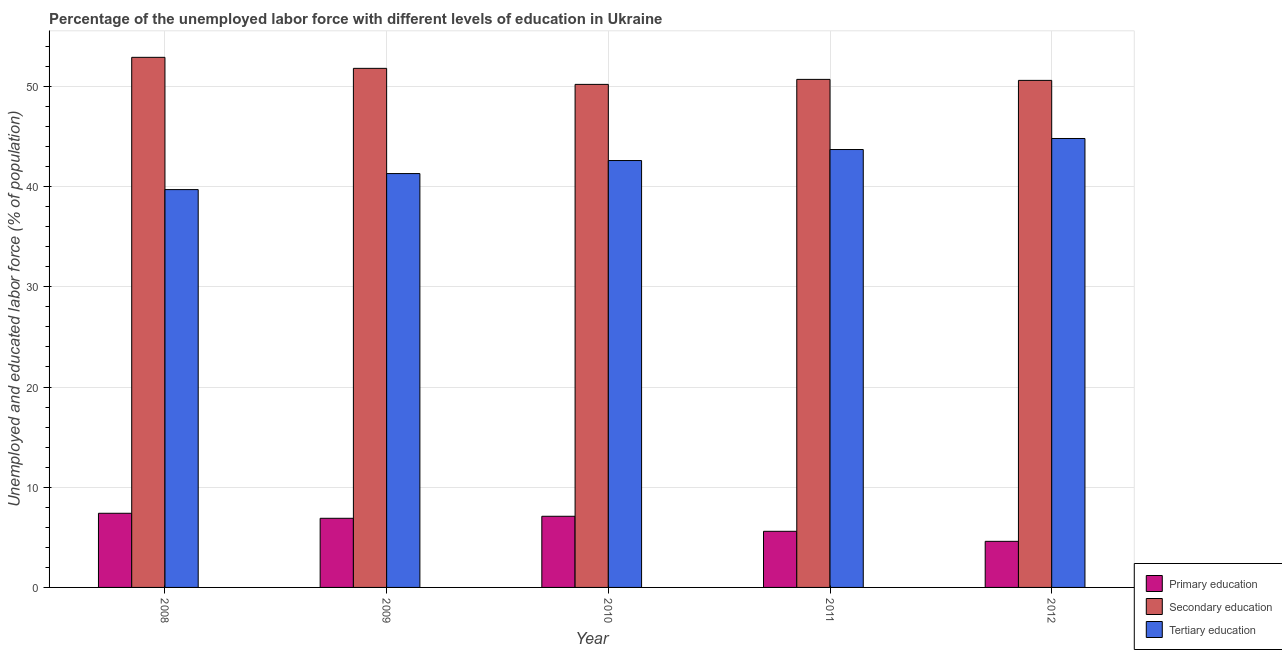How many groups of bars are there?
Provide a succinct answer. 5. Are the number of bars per tick equal to the number of legend labels?
Make the answer very short. Yes. What is the label of the 5th group of bars from the left?
Provide a short and direct response. 2012. In how many cases, is the number of bars for a given year not equal to the number of legend labels?
Offer a terse response. 0. What is the percentage of labor force who received tertiary education in 2009?
Make the answer very short. 41.3. Across all years, what is the maximum percentage of labor force who received primary education?
Make the answer very short. 7.4. Across all years, what is the minimum percentage of labor force who received primary education?
Keep it short and to the point. 4.6. In which year was the percentage of labor force who received tertiary education minimum?
Provide a succinct answer. 2008. What is the total percentage of labor force who received secondary education in the graph?
Your answer should be very brief. 256.2. What is the difference between the percentage of labor force who received tertiary education in 2009 and that in 2012?
Make the answer very short. -3.5. What is the difference between the percentage of labor force who received tertiary education in 2010 and the percentage of labor force who received secondary education in 2009?
Make the answer very short. 1.3. What is the average percentage of labor force who received secondary education per year?
Offer a very short reply. 51.24. What is the ratio of the percentage of labor force who received primary education in 2009 to that in 2012?
Give a very brief answer. 1.5. Is the difference between the percentage of labor force who received tertiary education in 2008 and 2011 greater than the difference between the percentage of labor force who received secondary education in 2008 and 2011?
Offer a very short reply. No. What is the difference between the highest and the second highest percentage of labor force who received secondary education?
Give a very brief answer. 1.1. What is the difference between the highest and the lowest percentage of labor force who received secondary education?
Give a very brief answer. 2.7. In how many years, is the percentage of labor force who received primary education greater than the average percentage of labor force who received primary education taken over all years?
Give a very brief answer. 3. What does the 1st bar from the left in 2012 represents?
Keep it short and to the point. Primary education. What does the 2nd bar from the right in 2012 represents?
Your answer should be very brief. Secondary education. Is it the case that in every year, the sum of the percentage of labor force who received primary education and percentage of labor force who received secondary education is greater than the percentage of labor force who received tertiary education?
Your response must be concise. Yes. How many bars are there?
Make the answer very short. 15. How many years are there in the graph?
Your answer should be compact. 5. What is the difference between two consecutive major ticks on the Y-axis?
Ensure brevity in your answer.  10. Are the values on the major ticks of Y-axis written in scientific E-notation?
Offer a terse response. No. Does the graph contain any zero values?
Provide a succinct answer. No. Does the graph contain grids?
Your response must be concise. Yes. Where does the legend appear in the graph?
Provide a short and direct response. Bottom right. How many legend labels are there?
Offer a terse response. 3. What is the title of the graph?
Your answer should be compact. Percentage of the unemployed labor force with different levels of education in Ukraine. What is the label or title of the X-axis?
Offer a terse response. Year. What is the label or title of the Y-axis?
Provide a succinct answer. Unemployed and educated labor force (% of population). What is the Unemployed and educated labor force (% of population) in Primary education in 2008?
Your answer should be compact. 7.4. What is the Unemployed and educated labor force (% of population) in Secondary education in 2008?
Ensure brevity in your answer.  52.9. What is the Unemployed and educated labor force (% of population) in Tertiary education in 2008?
Give a very brief answer. 39.7. What is the Unemployed and educated labor force (% of population) in Primary education in 2009?
Your answer should be compact. 6.9. What is the Unemployed and educated labor force (% of population) of Secondary education in 2009?
Offer a terse response. 51.8. What is the Unemployed and educated labor force (% of population) in Tertiary education in 2009?
Give a very brief answer. 41.3. What is the Unemployed and educated labor force (% of population) in Primary education in 2010?
Give a very brief answer. 7.1. What is the Unemployed and educated labor force (% of population) of Secondary education in 2010?
Make the answer very short. 50.2. What is the Unemployed and educated labor force (% of population) of Tertiary education in 2010?
Ensure brevity in your answer.  42.6. What is the Unemployed and educated labor force (% of population) in Primary education in 2011?
Your answer should be compact. 5.6. What is the Unemployed and educated labor force (% of population) in Secondary education in 2011?
Make the answer very short. 50.7. What is the Unemployed and educated labor force (% of population) in Tertiary education in 2011?
Offer a very short reply. 43.7. What is the Unemployed and educated labor force (% of population) of Primary education in 2012?
Provide a short and direct response. 4.6. What is the Unemployed and educated labor force (% of population) of Secondary education in 2012?
Offer a terse response. 50.6. What is the Unemployed and educated labor force (% of population) of Tertiary education in 2012?
Offer a terse response. 44.8. Across all years, what is the maximum Unemployed and educated labor force (% of population) of Primary education?
Keep it short and to the point. 7.4. Across all years, what is the maximum Unemployed and educated labor force (% of population) of Secondary education?
Give a very brief answer. 52.9. Across all years, what is the maximum Unemployed and educated labor force (% of population) in Tertiary education?
Your answer should be very brief. 44.8. Across all years, what is the minimum Unemployed and educated labor force (% of population) of Primary education?
Provide a succinct answer. 4.6. Across all years, what is the minimum Unemployed and educated labor force (% of population) in Secondary education?
Give a very brief answer. 50.2. Across all years, what is the minimum Unemployed and educated labor force (% of population) in Tertiary education?
Your answer should be compact. 39.7. What is the total Unemployed and educated labor force (% of population) of Primary education in the graph?
Provide a short and direct response. 31.6. What is the total Unemployed and educated labor force (% of population) in Secondary education in the graph?
Your answer should be very brief. 256.2. What is the total Unemployed and educated labor force (% of population) of Tertiary education in the graph?
Your answer should be compact. 212.1. What is the difference between the Unemployed and educated labor force (% of population) of Primary education in 2008 and that in 2009?
Offer a terse response. 0.5. What is the difference between the Unemployed and educated labor force (% of population) of Secondary education in 2008 and that in 2010?
Offer a terse response. 2.7. What is the difference between the Unemployed and educated labor force (% of population) in Primary education in 2008 and that in 2011?
Keep it short and to the point. 1.8. What is the difference between the Unemployed and educated labor force (% of population) of Secondary education in 2008 and that in 2011?
Provide a succinct answer. 2.2. What is the difference between the Unemployed and educated labor force (% of population) of Tertiary education in 2008 and that in 2011?
Provide a succinct answer. -4. What is the difference between the Unemployed and educated labor force (% of population) of Secondary education in 2008 and that in 2012?
Provide a succinct answer. 2.3. What is the difference between the Unemployed and educated labor force (% of population) of Primary education in 2009 and that in 2010?
Offer a very short reply. -0.2. What is the difference between the Unemployed and educated labor force (% of population) in Secondary education in 2009 and that in 2010?
Your answer should be very brief. 1.6. What is the difference between the Unemployed and educated labor force (% of population) of Secondary education in 2009 and that in 2011?
Make the answer very short. 1.1. What is the difference between the Unemployed and educated labor force (% of population) in Tertiary education in 2009 and that in 2011?
Ensure brevity in your answer.  -2.4. What is the difference between the Unemployed and educated labor force (% of population) of Secondary education in 2009 and that in 2012?
Your answer should be compact. 1.2. What is the difference between the Unemployed and educated labor force (% of population) in Primary education in 2010 and that in 2011?
Your answer should be compact. 1.5. What is the difference between the Unemployed and educated labor force (% of population) in Secondary education in 2010 and that in 2011?
Give a very brief answer. -0.5. What is the difference between the Unemployed and educated labor force (% of population) of Primary education in 2010 and that in 2012?
Your answer should be very brief. 2.5. What is the difference between the Unemployed and educated labor force (% of population) in Secondary education in 2010 and that in 2012?
Ensure brevity in your answer.  -0.4. What is the difference between the Unemployed and educated labor force (% of population) in Tertiary education in 2010 and that in 2012?
Your response must be concise. -2.2. What is the difference between the Unemployed and educated labor force (% of population) of Primary education in 2008 and the Unemployed and educated labor force (% of population) of Secondary education in 2009?
Your response must be concise. -44.4. What is the difference between the Unemployed and educated labor force (% of population) in Primary education in 2008 and the Unemployed and educated labor force (% of population) in Tertiary education in 2009?
Your answer should be very brief. -33.9. What is the difference between the Unemployed and educated labor force (% of population) of Primary education in 2008 and the Unemployed and educated labor force (% of population) of Secondary education in 2010?
Offer a very short reply. -42.8. What is the difference between the Unemployed and educated labor force (% of population) of Primary education in 2008 and the Unemployed and educated labor force (% of population) of Tertiary education in 2010?
Keep it short and to the point. -35.2. What is the difference between the Unemployed and educated labor force (% of population) in Primary education in 2008 and the Unemployed and educated labor force (% of population) in Secondary education in 2011?
Offer a very short reply. -43.3. What is the difference between the Unemployed and educated labor force (% of population) in Primary education in 2008 and the Unemployed and educated labor force (% of population) in Tertiary education in 2011?
Your answer should be compact. -36.3. What is the difference between the Unemployed and educated labor force (% of population) in Primary education in 2008 and the Unemployed and educated labor force (% of population) in Secondary education in 2012?
Ensure brevity in your answer.  -43.2. What is the difference between the Unemployed and educated labor force (% of population) in Primary education in 2008 and the Unemployed and educated labor force (% of population) in Tertiary education in 2012?
Ensure brevity in your answer.  -37.4. What is the difference between the Unemployed and educated labor force (% of population) of Secondary education in 2008 and the Unemployed and educated labor force (% of population) of Tertiary education in 2012?
Offer a very short reply. 8.1. What is the difference between the Unemployed and educated labor force (% of population) of Primary education in 2009 and the Unemployed and educated labor force (% of population) of Secondary education in 2010?
Your answer should be very brief. -43.3. What is the difference between the Unemployed and educated labor force (% of population) of Primary education in 2009 and the Unemployed and educated labor force (% of population) of Tertiary education in 2010?
Offer a very short reply. -35.7. What is the difference between the Unemployed and educated labor force (% of population) in Secondary education in 2009 and the Unemployed and educated labor force (% of population) in Tertiary education in 2010?
Offer a very short reply. 9.2. What is the difference between the Unemployed and educated labor force (% of population) in Primary education in 2009 and the Unemployed and educated labor force (% of population) in Secondary education in 2011?
Your answer should be very brief. -43.8. What is the difference between the Unemployed and educated labor force (% of population) in Primary education in 2009 and the Unemployed and educated labor force (% of population) in Tertiary education in 2011?
Provide a short and direct response. -36.8. What is the difference between the Unemployed and educated labor force (% of population) in Primary education in 2009 and the Unemployed and educated labor force (% of population) in Secondary education in 2012?
Provide a short and direct response. -43.7. What is the difference between the Unemployed and educated labor force (% of population) of Primary education in 2009 and the Unemployed and educated labor force (% of population) of Tertiary education in 2012?
Provide a succinct answer. -37.9. What is the difference between the Unemployed and educated labor force (% of population) in Primary education in 2010 and the Unemployed and educated labor force (% of population) in Secondary education in 2011?
Your answer should be compact. -43.6. What is the difference between the Unemployed and educated labor force (% of population) in Primary education in 2010 and the Unemployed and educated labor force (% of population) in Tertiary education in 2011?
Your response must be concise. -36.6. What is the difference between the Unemployed and educated labor force (% of population) in Secondary education in 2010 and the Unemployed and educated labor force (% of population) in Tertiary education in 2011?
Provide a succinct answer. 6.5. What is the difference between the Unemployed and educated labor force (% of population) in Primary education in 2010 and the Unemployed and educated labor force (% of population) in Secondary education in 2012?
Offer a terse response. -43.5. What is the difference between the Unemployed and educated labor force (% of population) in Primary education in 2010 and the Unemployed and educated labor force (% of population) in Tertiary education in 2012?
Offer a terse response. -37.7. What is the difference between the Unemployed and educated labor force (% of population) in Secondary education in 2010 and the Unemployed and educated labor force (% of population) in Tertiary education in 2012?
Your answer should be very brief. 5.4. What is the difference between the Unemployed and educated labor force (% of population) of Primary education in 2011 and the Unemployed and educated labor force (% of population) of Secondary education in 2012?
Your answer should be very brief. -45. What is the difference between the Unemployed and educated labor force (% of population) in Primary education in 2011 and the Unemployed and educated labor force (% of population) in Tertiary education in 2012?
Ensure brevity in your answer.  -39.2. What is the average Unemployed and educated labor force (% of population) of Primary education per year?
Provide a short and direct response. 6.32. What is the average Unemployed and educated labor force (% of population) of Secondary education per year?
Your response must be concise. 51.24. What is the average Unemployed and educated labor force (% of population) of Tertiary education per year?
Ensure brevity in your answer.  42.42. In the year 2008, what is the difference between the Unemployed and educated labor force (% of population) in Primary education and Unemployed and educated labor force (% of population) in Secondary education?
Provide a succinct answer. -45.5. In the year 2008, what is the difference between the Unemployed and educated labor force (% of population) of Primary education and Unemployed and educated labor force (% of population) of Tertiary education?
Provide a succinct answer. -32.3. In the year 2008, what is the difference between the Unemployed and educated labor force (% of population) in Secondary education and Unemployed and educated labor force (% of population) in Tertiary education?
Ensure brevity in your answer.  13.2. In the year 2009, what is the difference between the Unemployed and educated labor force (% of population) in Primary education and Unemployed and educated labor force (% of population) in Secondary education?
Keep it short and to the point. -44.9. In the year 2009, what is the difference between the Unemployed and educated labor force (% of population) of Primary education and Unemployed and educated labor force (% of population) of Tertiary education?
Offer a terse response. -34.4. In the year 2010, what is the difference between the Unemployed and educated labor force (% of population) in Primary education and Unemployed and educated labor force (% of population) in Secondary education?
Provide a short and direct response. -43.1. In the year 2010, what is the difference between the Unemployed and educated labor force (% of population) of Primary education and Unemployed and educated labor force (% of population) of Tertiary education?
Give a very brief answer. -35.5. In the year 2011, what is the difference between the Unemployed and educated labor force (% of population) of Primary education and Unemployed and educated labor force (% of population) of Secondary education?
Your answer should be very brief. -45.1. In the year 2011, what is the difference between the Unemployed and educated labor force (% of population) in Primary education and Unemployed and educated labor force (% of population) in Tertiary education?
Your answer should be very brief. -38.1. In the year 2011, what is the difference between the Unemployed and educated labor force (% of population) of Secondary education and Unemployed and educated labor force (% of population) of Tertiary education?
Offer a very short reply. 7. In the year 2012, what is the difference between the Unemployed and educated labor force (% of population) of Primary education and Unemployed and educated labor force (% of population) of Secondary education?
Ensure brevity in your answer.  -46. In the year 2012, what is the difference between the Unemployed and educated labor force (% of population) of Primary education and Unemployed and educated labor force (% of population) of Tertiary education?
Your answer should be very brief. -40.2. In the year 2012, what is the difference between the Unemployed and educated labor force (% of population) of Secondary education and Unemployed and educated labor force (% of population) of Tertiary education?
Your answer should be compact. 5.8. What is the ratio of the Unemployed and educated labor force (% of population) in Primary education in 2008 to that in 2009?
Give a very brief answer. 1.07. What is the ratio of the Unemployed and educated labor force (% of population) in Secondary education in 2008 to that in 2009?
Ensure brevity in your answer.  1.02. What is the ratio of the Unemployed and educated labor force (% of population) of Tertiary education in 2008 to that in 2009?
Provide a short and direct response. 0.96. What is the ratio of the Unemployed and educated labor force (% of population) in Primary education in 2008 to that in 2010?
Offer a terse response. 1.04. What is the ratio of the Unemployed and educated labor force (% of population) of Secondary education in 2008 to that in 2010?
Offer a terse response. 1.05. What is the ratio of the Unemployed and educated labor force (% of population) in Tertiary education in 2008 to that in 2010?
Provide a succinct answer. 0.93. What is the ratio of the Unemployed and educated labor force (% of population) in Primary education in 2008 to that in 2011?
Keep it short and to the point. 1.32. What is the ratio of the Unemployed and educated labor force (% of population) in Secondary education in 2008 to that in 2011?
Give a very brief answer. 1.04. What is the ratio of the Unemployed and educated labor force (% of population) of Tertiary education in 2008 to that in 2011?
Your answer should be compact. 0.91. What is the ratio of the Unemployed and educated labor force (% of population) in Primary education in 2008 to that in 2012?
Keep it short and to the point. 1.61. What is the ratio of the Unemployed and educated labor force (% of population) of Secondary education in 2008 to that in 2012?
Your response must be concise. 1.05. What is the ratio of the Unemployed and educated labor force (% of population) in Tertiary education in 2008 to that in 2012?
Provide a succinct answer. 0.89. What is the ratio of the Unemployed and educated labor force (% of population) in Primary education in 2009 to that in 2010?
Provide a short and direct response. 0.97. What is the ratio of the Unemployed and educated labor force (% of population) in Secondary education in 2009 to that in 2010?
Keep it short and to the point. 1.03. What is the ratio of the Unemployed and educated labor force (% of population) in Tertiary education in 2009 to that in 2010?
Your response must be concise. 0.97. What is the ratio of the Unemployed and educated labor force (% of population) in Primary education in 2009 to that in 2011?
Offer a very short reply. 1.23. What is the ratio of the Unemployed and educated labor force (% of population) in Secondary education in 2009 to that in 2011?
Your answer should be compact. 1.02. What is the ratio of the Unemployed and educated labor force (% of population) in Tertiary education in 2009 to that in 2011?
Your answer should be compact. 0.95. What is the ratio of the Unemployed and educated labor force (% of population) in Secondary education in 2009 to that in 2012?
Offer a terse response. 1.02. What is the ratio of the Unemployed and educated labor force (% of population) in Tertiary education in 2009 to that in 2012?
Keep it short and to the point. 0.92. What is the ratio of the Unemployed and educated labor force (% of population) in Primary education in 2010 to that in 2011?
Give a very brief answer. 1.27. What is the ratio of the Unemployed and educated labor force (% of population) of Secondary education in 2010 to that in 2011?
Ensure brevity in your answer.  0.99. What is the ratio of the Unemployed and educated labor force (% of population) of Tertiary education in 2010 to that in 2011?
Keep it short and to the point. 0.97. What is the ratio of the Unemployed and educated labor force (% of population) of Primary education in 2010 to that in 2012?
Give a very brief answer. 1.54. What is the ratio of the Unemployed and educated labor force (% of population) in Tertiary education in 2010 to that in 2012?
Keep it short and to the point. 0.95. What is the ratio of the Unemployed and educated labor force (% of population) of Primary education in 2011 to that in 2012?
Ensure brevity in your answer.  1.22. What is the ratio of the Unemployed and educated labor force (% of population) in Secondary education in 2011 to that in 2012?
Ensure brevity in your answer.  1. What is the ratio of the Unemployed and educated labor force (% of population) of Tertiary education in 2011 to that in 2012?
Ensure brevity in your answer.  0.98. What is the difference between the highest and the second highest Unemployed and educated labor force (% of population) of Primary education?
Ensure brevity in your answer.  0.3. What is the difference between the highest and the second highest Unemployed and educated labor force (% of population) in Secondary education?
Make the answer very short. 1.1. What is the difference between the highest and the lowest Unemployed and educated labor force (% of population) in Secondary education?
Give a very brief answer. 2.7. 